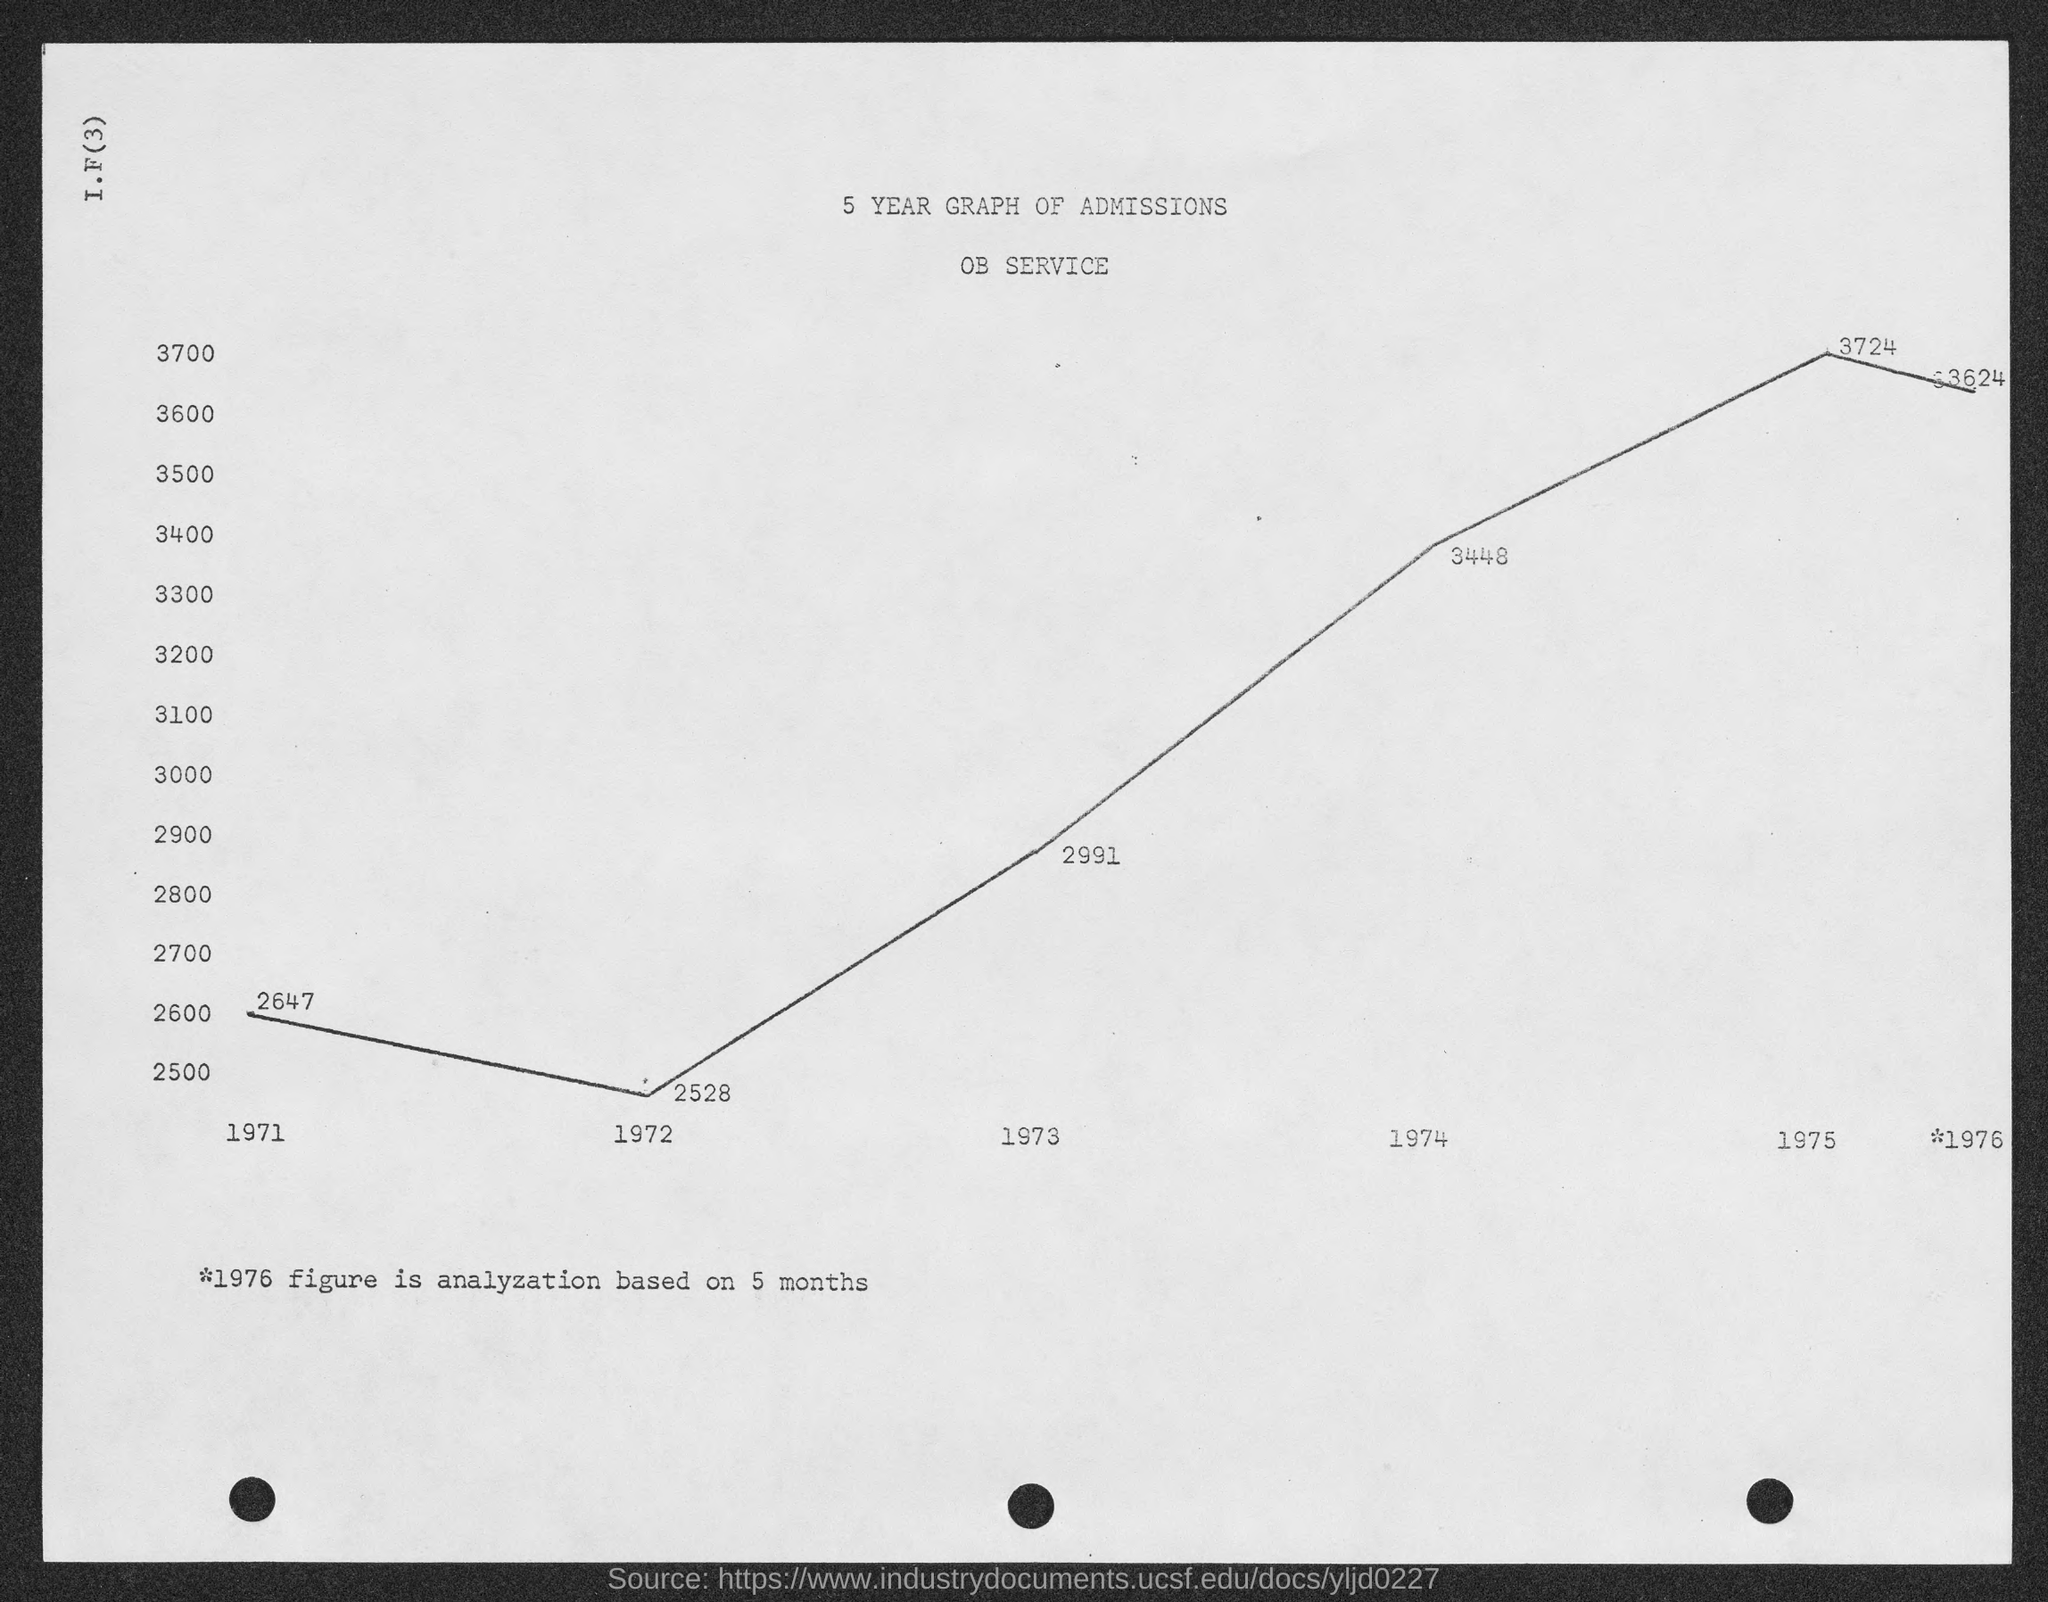Mention a couple of crucial points in this snapshot. The number of admissions in 1972, as shown in the graph, was 2528. The graph shows that there were 2,991 admissions in the year 1973. In the year 1974, there were 3,448 admissions as shown by the graph. The graph shows the number of admissions in the year 1971, which is 2647. In 1975, the number of admissions was 3,724, as shown in the graph. 